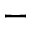Convert formula to latex. <formula><loc_0><loc_0><loc_500><loc_500>-</formula> 